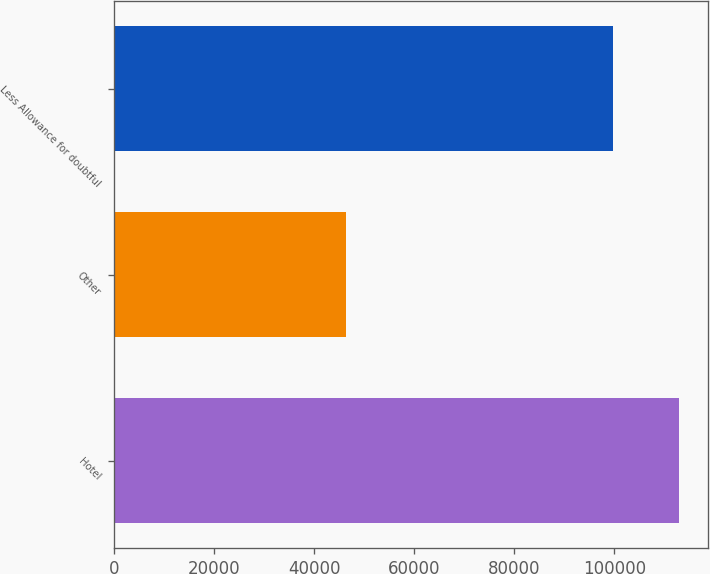Convert chart to OTSL. <chart><loc_0><loc_0><loc_500><loc_500><bar_chart><fcel>Hotel<fcel>Other<fcel>Less Allowance for doubtful<nl><fcel>112985<fcel>46437<fcel>99606<nl></chart> 